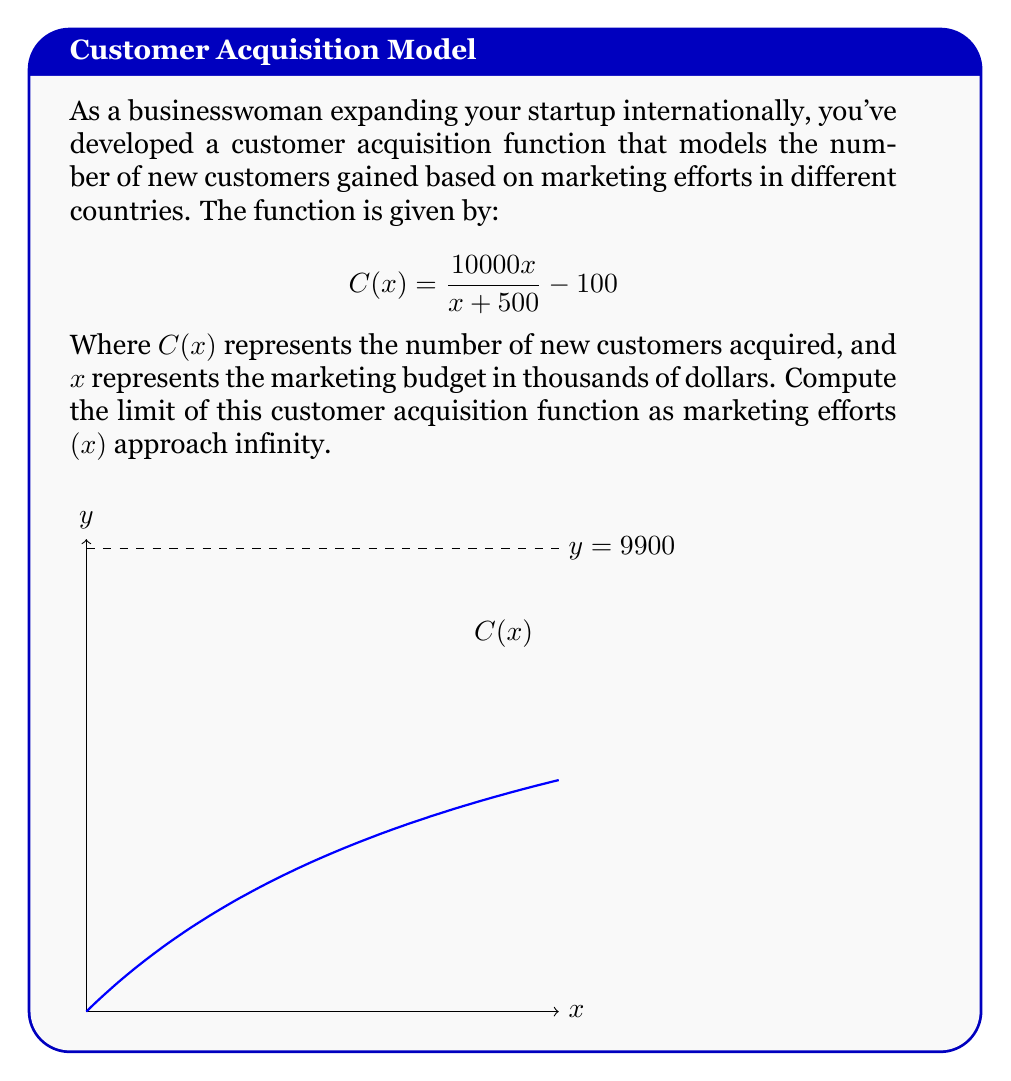Show me your answer to this math problem. To find the limit of $C(x)$ as $x$ approaches infinity, we'll follow these steps:

1) First, let's rewrite the function in a form that's easier to evaluate as $x$ approaches infinity:

   $$\lim_{x \to \infty} C(x) = \lim_{x \to \infty} \left(\frac{10000x}{x + 500} - 100\right)$$

2) We can separate this into two limits:

   $$\lim_{x \to \infty} \frac{10000x}{x + 500} - \lim_{x \to \infty} 100$$

3) The second limit is straightforward: $\lim_{x \to \infty} 100 = 100$

4) For the first limit, we can divide both numerator and denominator by x:

   $$\lim_{x \to \infty} \frac{10000x}{x + 500} = \lim_{x \to \infty} \frac{10000}{\frac{x + 500}{x}} = \lim_{x \to \infty} \frac{10000}{1 + \frac{500}{x}}$$

5) As $x$ approaches infinity, $\frac{500}{x}$ approaches 0, so:

   $$\lim_{x \to \infty} \frac{10000}{1 + \frac{500}{x}} = \frac{10000}{1 + 0} = 10000$$

6) Now, we can combine our results:

   $$\lim_{x \to \infty} C(x) = 10000 - 100 = 9900$$

This means that as the marketing budget approaches infinity, the number of new customers acquired approaches 9900.
Answer: 9900 